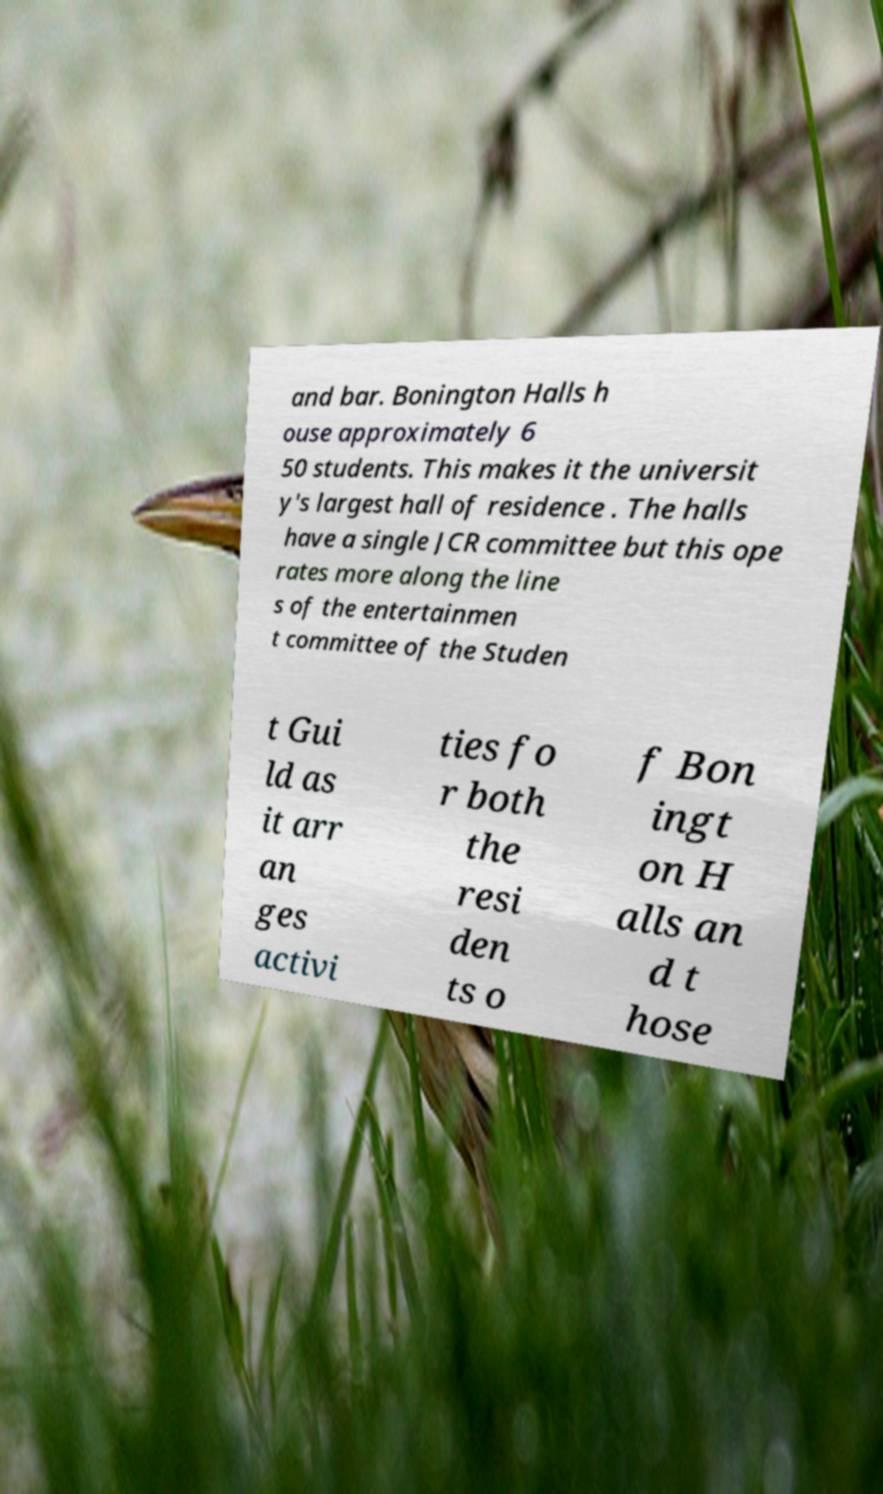Could you assist in decoding the text presented in this image and type it out clearly? and bar. Bonington Halls h ouse approximately 6 50 students. This makes it the universit y's largest hall of residence . The halls have a single JCR committee but this ope rates more along the line s of the entertainmen t committee of the Studen t Gui ld as it arr an ges activi ties fo r both the resi den ts o f Bon ingt on H alls an d t hose 